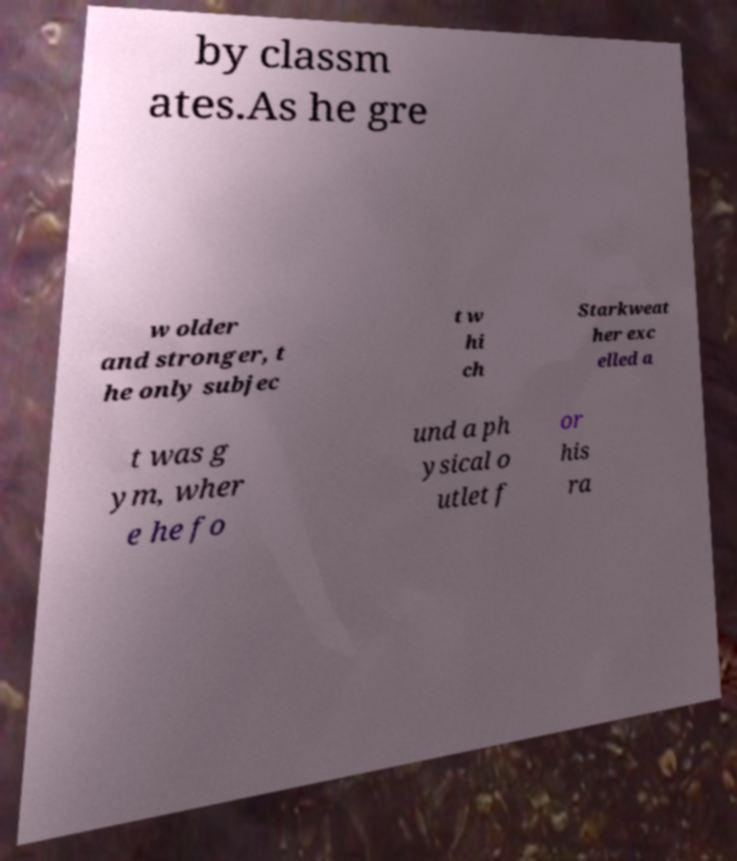There's text embedded in this image that I need extracted. Can you transcribe it verbatim? by classm ates.As he gre w older and stronger, t he only subjec t w hi ch Starkweat her exc elled a t was g ym, wher e he fo und a ph ysical o utlet f or his ra 